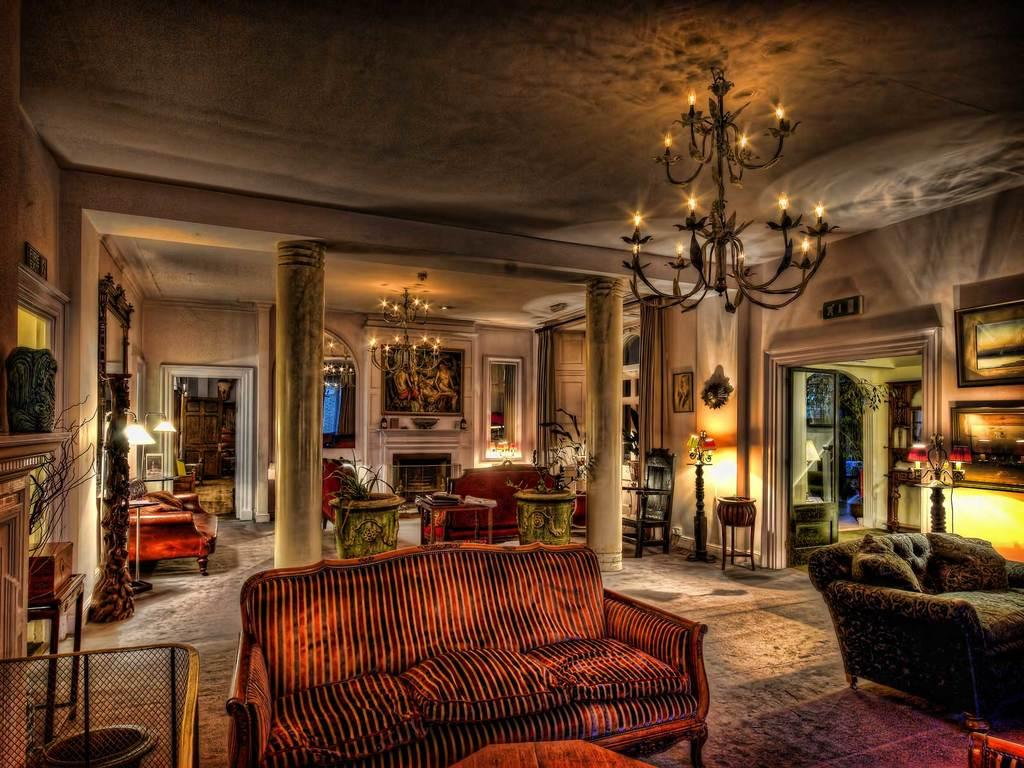What type of room is shown in the image? The image depicts a living room. What furniture is present in the living room? There are sofa sets in the living room. Are there any lighting fixtures in the living room? Yes, there are lamps in the living room. What type of decorative items can be seen in the living room? There are photo frames in the living room. Is there another room connected to the living room? Yes, there is another room adjacent to the living room. How are the two rooms separated? There are two pillars between the living room and the adjacent room. What is the reaction of the people in the living room when they experience a shock from the rain? There are no people present in the image, and there is no mention of rain or shock, so this situation cannot be observed. 